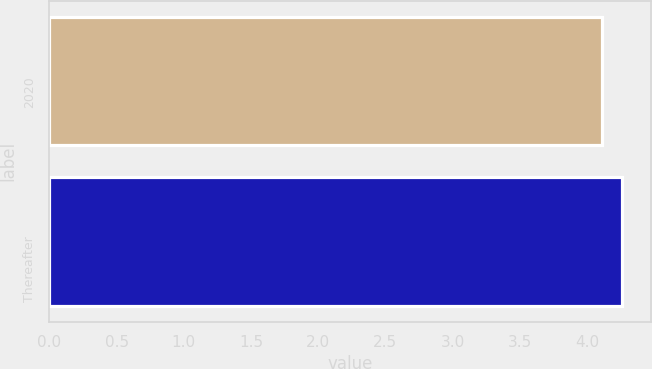Convert chart. <chart><loc_0><loc_0><loc_500><loc_500><bar_chart><fcel>2020<fcel>Thereafter<nl><fcel>4.11<fcel>4.26<nl></chart> 